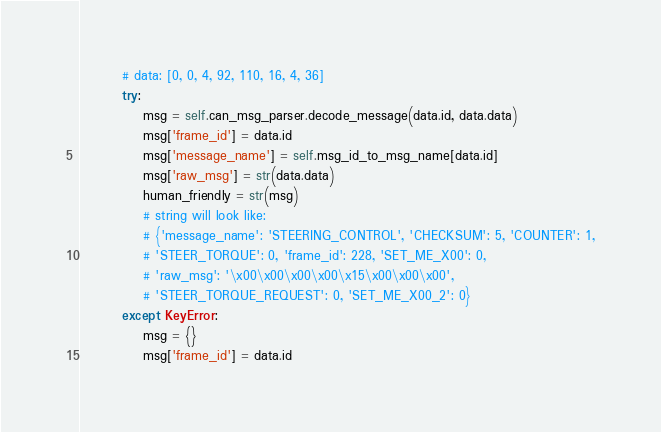Convert code to text. <code><loc_0><loc_0><loc_500><loc_500><_Python_>        # data: [0, 0, 4, 92, 110, 16, 4, 36]
        try:
            msg = self.can_msg_parser.decode_message(data.id, data.data)
            msg['frame_id'] = data.id
            msg['message_name'] = self.msg_id_to_msg_name[data.id]
            msg['raw_msg'] = str(data.data)
            human_friendly = str(msg)
            # string will look like:
            # {'message_name': 'STEERING_CONTROL', 'CHECKSUM': 5, 'COUNTER': 1,
            # 'STEER_TORQUE': 0, 'frame_id': 228, 'SET_ME_X00': 0,
            # 'raw_msg': '\x00\x00\x00\x00\x15\x00\x00\x00',
            # 'STEER_TORQUE_REQUEST': 0, 'SET_ME_X00_2': 0}
        except KeyError:
            msg = {}
            msg['frame_id'] = data.id</code> 